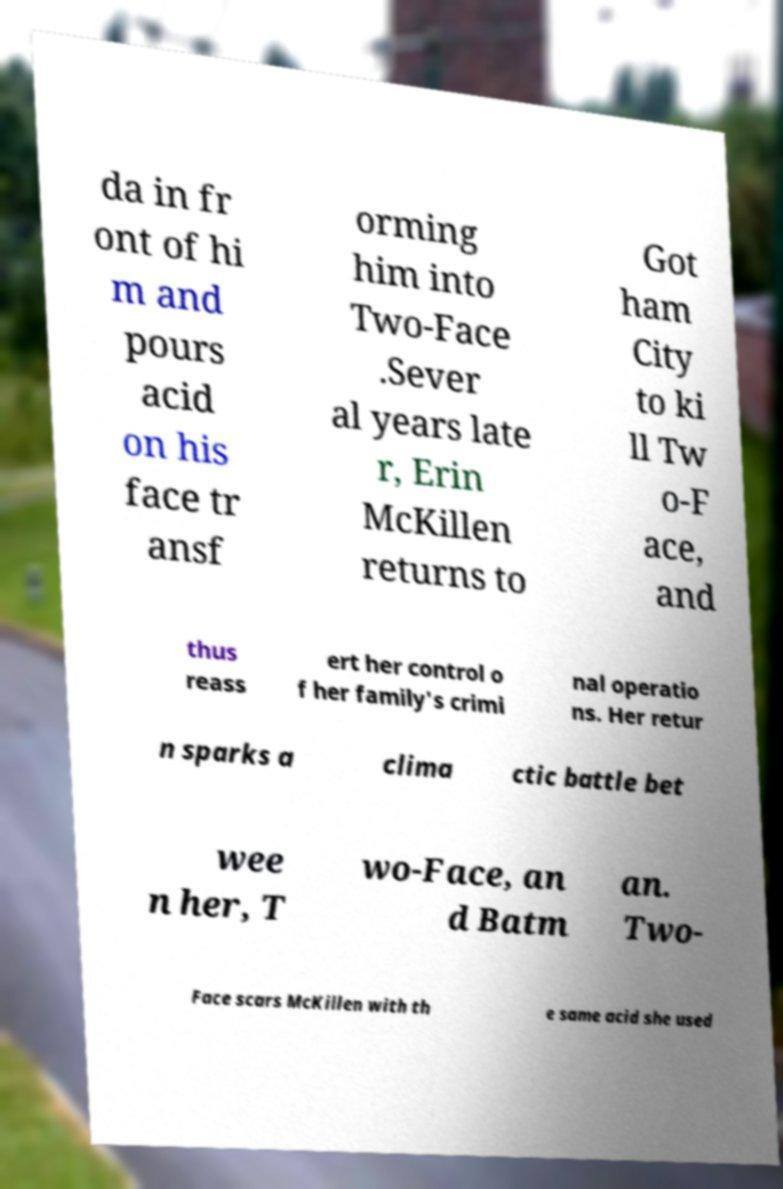There's text embedded in this image that I need extracted. Can you transcribe it verbatim? da in fr ont of hi m and pours acid on his face tr ansf orming him into Two-Face .Sever al years late r, Erin McKillen returns to Got ham City to ki ll Tw o-F ace, and thus reass ert her control o f her family's crimi nal operatio ns. Her retur n sparks a clima ctic battle bet wee n her, T wo-Face, an d Batm an. Two- Face scars McKillen with th e same acid she used 